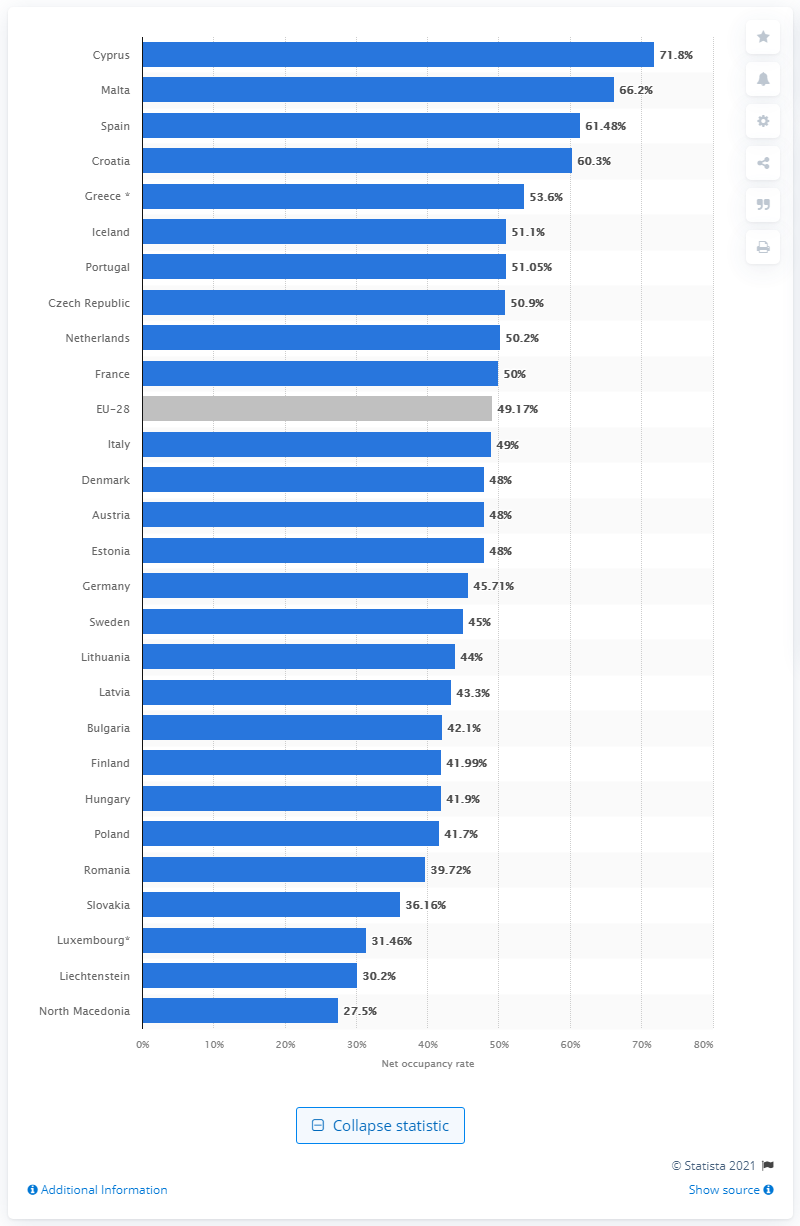Mention a couple of crucial points in this snapshot. In 2019, the net occupancy rate of bed spaces in hotels in Cyprus was 71.8%. 